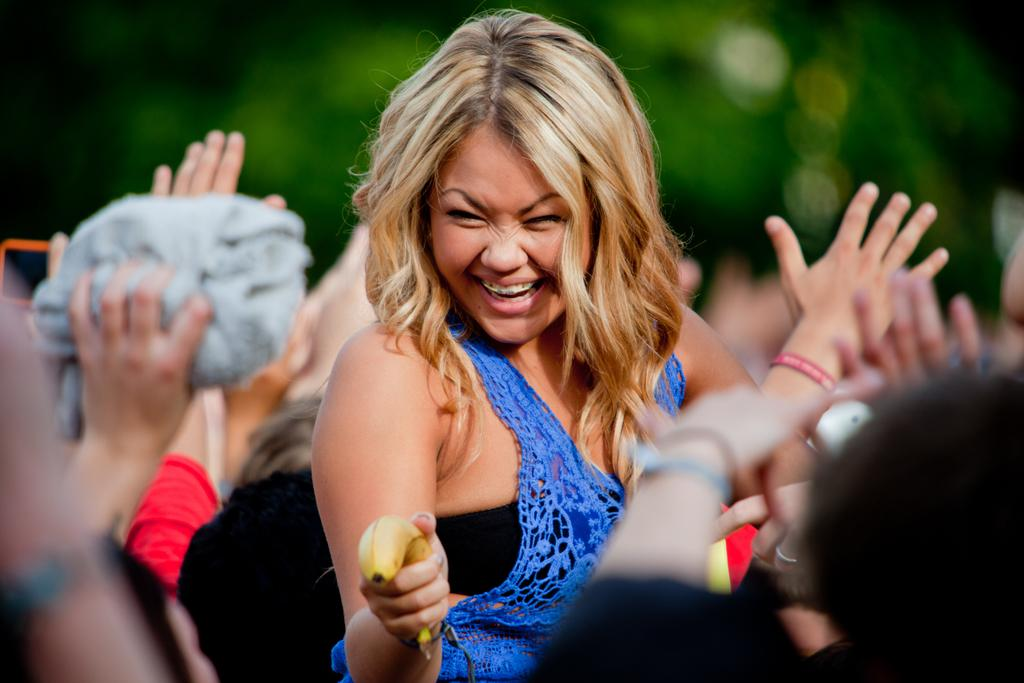Who is the main subject in the center of the picture? There is a woman in the center of the picture. What is the woman holding in the image? The woman is holding a banana. Can you describe the people in the foreground of the image? There are people in the foreground of the image, but their specific features are not clear due to the provided fact that the background is blurred. What type of lumber is being used to build the donkey in the image? There is no lumber or donkey present in the image; it features a woman holding a banana. 